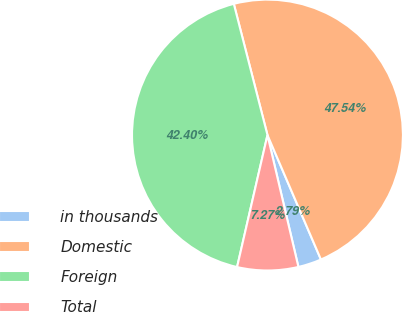Convert chart. <chart><loc_0><loc_0><loc_500><loc_500><pie_chart><fcel>in thousands<fcel>Domestic<fcel>Foreign<fcel>Total<nl><fcel>2.79%<fcel>47.54%<fcel>42.4%<fcel>7.27%<nl></chart> 